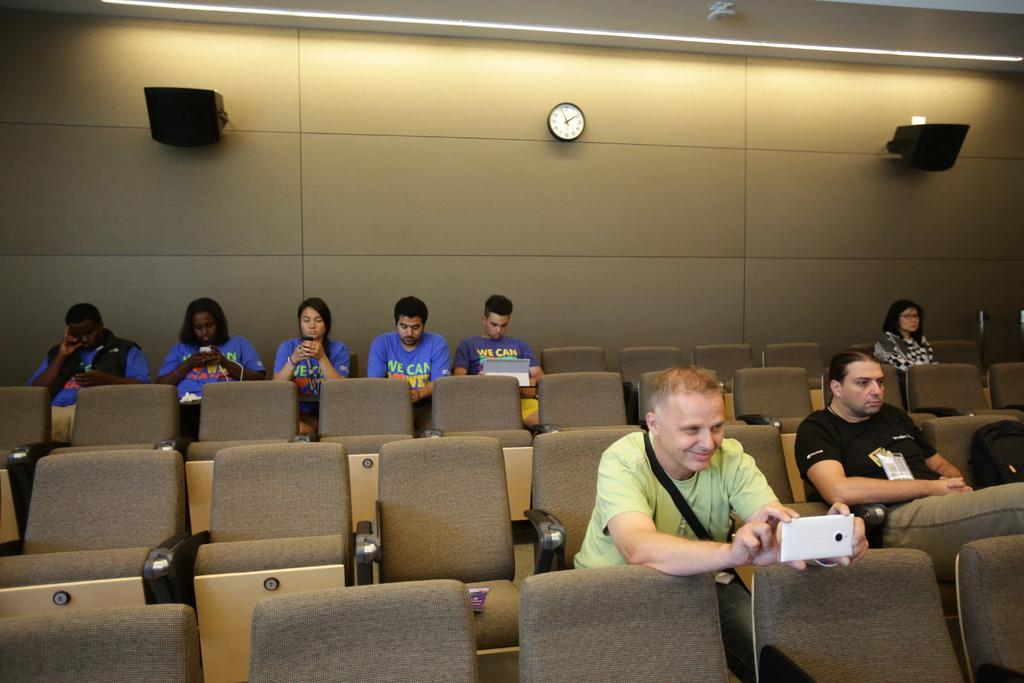Provide a one-sentence caption for the provided image. a hall with people in blue shirts that say we can. 